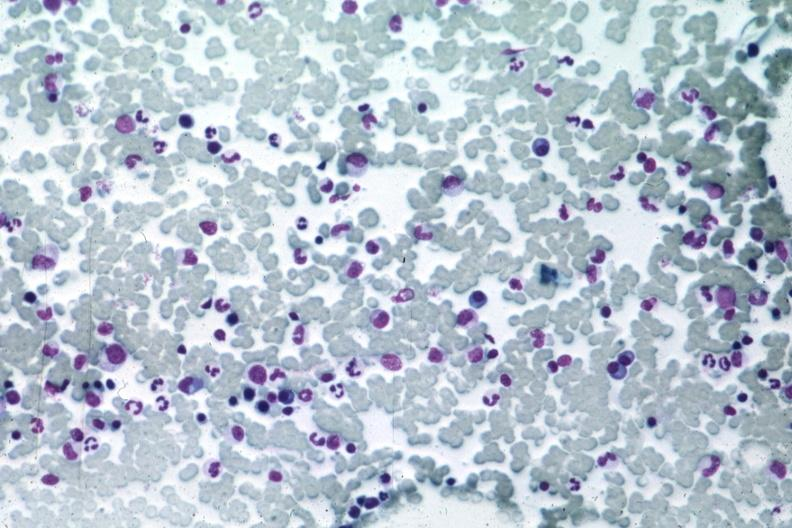s papillary intraductal adenocarcinoma present?
Answer the question using a single word or phrase. No 